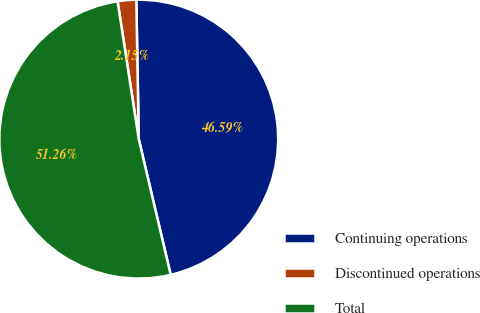Convert chart to OTSL. <chart><loc_0><loc_0><loc_500><loc_500><pie_chart><fcel>Continuing operations<fcel>Discontinued operations<fcel>Total<nl><fcel>46.59%<fcel>2.15%<fcel>51.25%<nl></chart> 